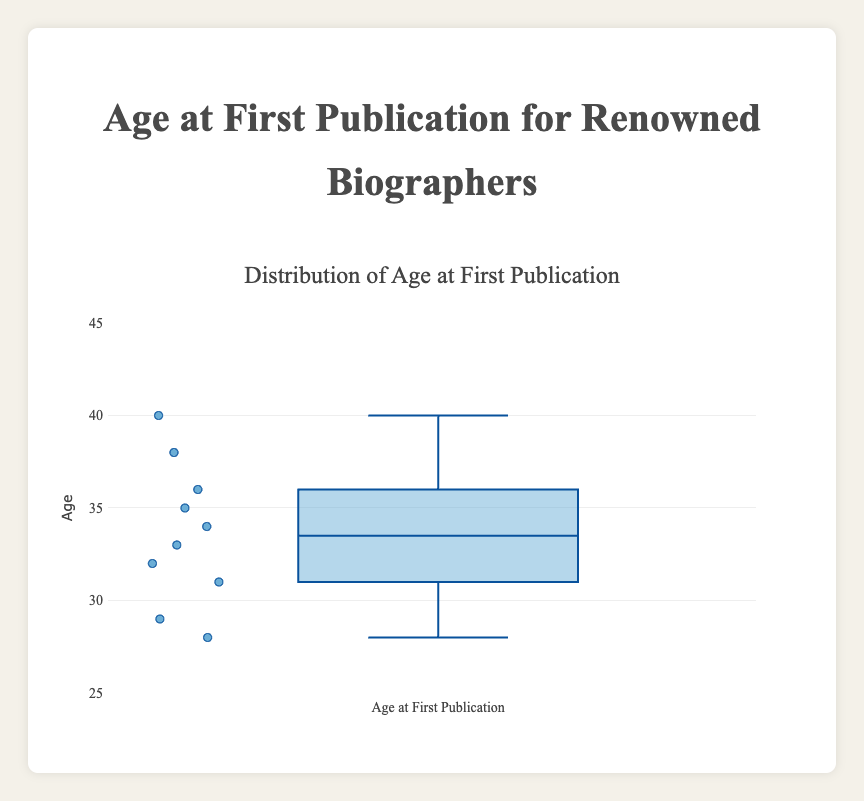What is the title of the box plot? The title is displayed at the top center of the plot.
Answer: Distribution of Age at First Publication How many data points are plotted in the box plot? To find the number of data points, count all individual data points on the plot.
Answer: 10 What is the median age at first publication? The median is the middle value of the dataset when ordered. In a box plot, this is marked by the horizontal line inside the box.
Answer: 33.5 Which biographer had the youngest age at first publication? The youngest age corresponds to the lowest point in the dataset. In the box plot, this is the lower whisker or the minimum point.
Answer: Doris Kearns Goodwin What is the age range of the first publication for these biographers? The age range can be found by subtracting the minimum value (lower whisker) from the maximum value (upper whisker).
Answer: 40 - 28 = 12 What is the interquartile range (IQR) of the ages at first publication? The IQR is the range between the 1st quartile (the bottom of the box) and the 3rd quartile (the top of the box).
Answer: 36 - 31 = 5 What is the mean age at first publication for these biographers? To find the mean, add all the ages and divide by the number of biographers: (34 + 40 + 28 + 31 + 38 + 29 + 33 + 35 + 32 + 36) / 10 = 336 / 10
Answer: 33.6 How does the median compare to the mean age at first publication? Compare the median value (33.5) to the mean value (33.6).
Answer: They are almost equal What is the age difference between the oldest and youngest biographers at their first publication? Subtract the minimum age from the maximum age in the dataset: 40 - 28 = 12.
Answer: 12 Are there any outliers in the dataset? If so, what ages are they? In a box plot, outliers are typically marked as individual points outside the whiskers. Here, there are no points marked as outliers.
Answer: No outliers 